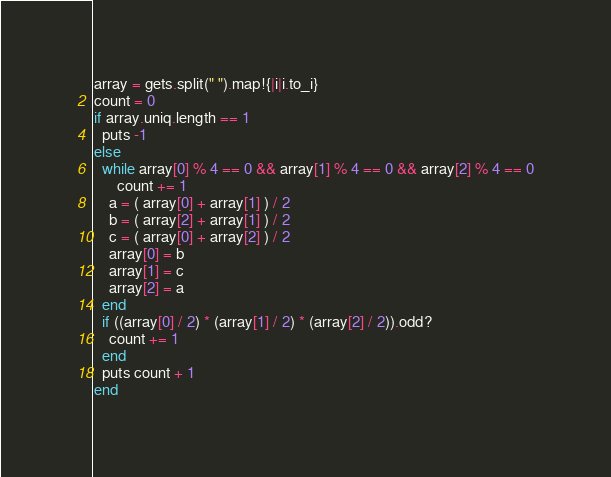<code> <loc_0><loc_0><loc_500><loc_500><_Ruby_>array = gets.split(" ").map!{|i|i.to_i}
count = 0
if array.uniq.length == 1
  puts -1
else
  while array[0] % 4 == 0 && array[1] % 4 == 0 && array[2] % 4 == 0
      count += 1
    a = ( array[0] + array[1] ) / 2
    b = ( array[2] + array[1] ) / 2
    c = ( array[0] + array[2] ) / 2
    array[0] = b
    array[1] = c
    array[2] = a
  end
  if ((array[0] / 2) * (array[1] / 2) * (array[2] / 2)).odd?
    count += 1
  end
  puts count + 1
end</code> 